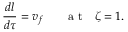Convert formula to latex. <formula><loc_0><loc_0><loc_500><loc_500>\frac { d l } { d \tau } = v _ { f } a t \zeta = 1 .</formula> 